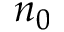Convert formula to latex. <formula><loc_0><loc_0><loc_500><loc_500>n _ { 0 }</formula> 